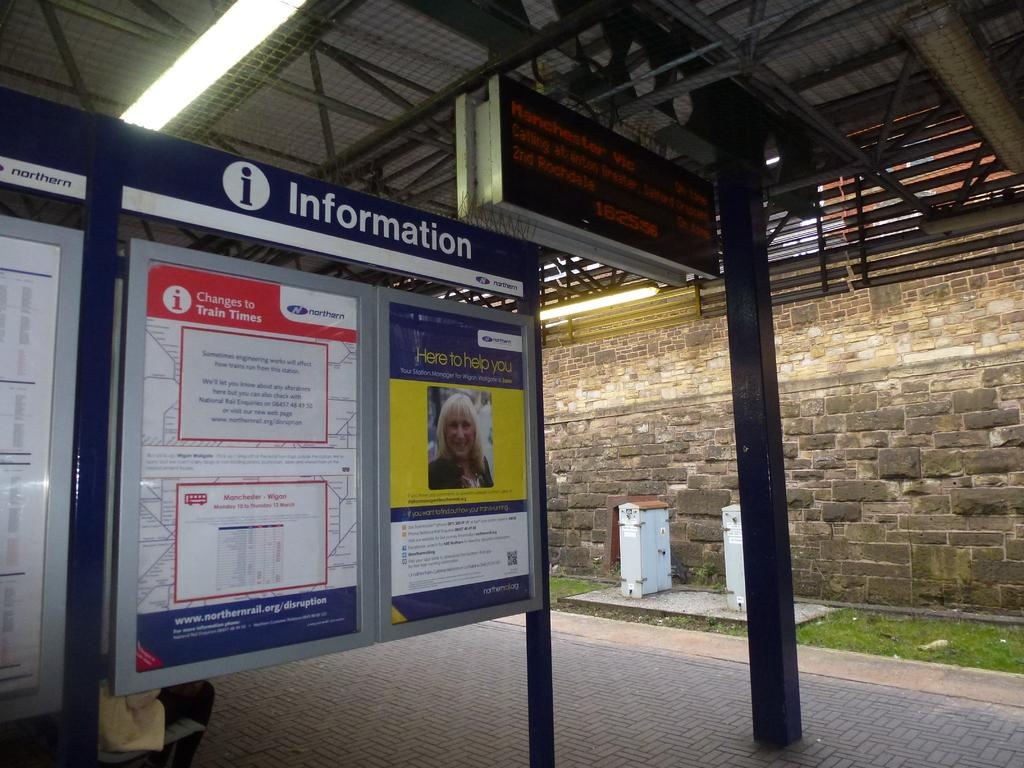Provide a one-sentence caption for the provided image. An information board at a train station with train times for today. 